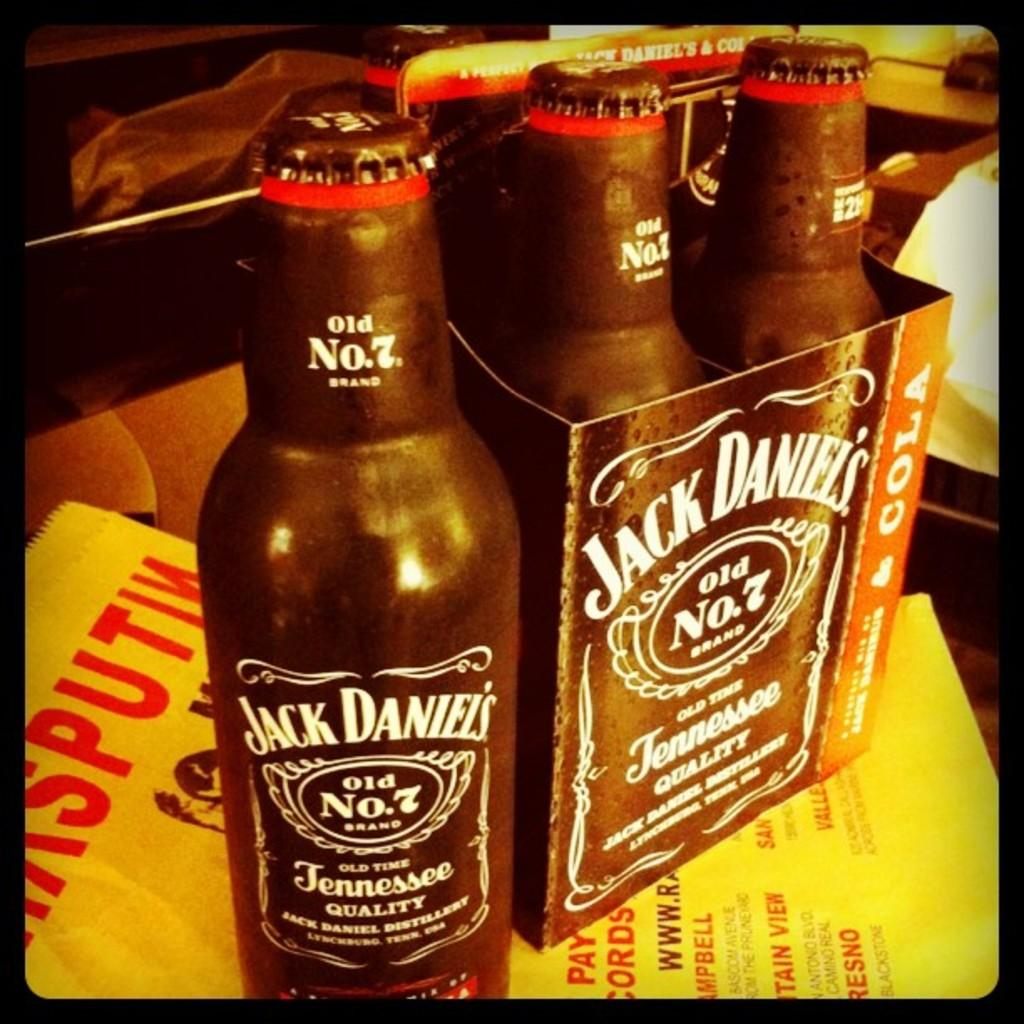<image>
Provide a brief description of the given image. A bottle of Jack Daniel's old number 7 is standing alone, in front of a four pack of these. 